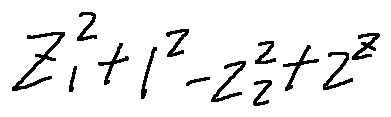Convert formula to latex. <formula><loc_0><loc_0><loc_500><loc_500>z _ { 1 } ^ { 2 } + 1 ^ { z } - z _ { 2 } ^ { 2 } + 2 ^ { z }</formula> 